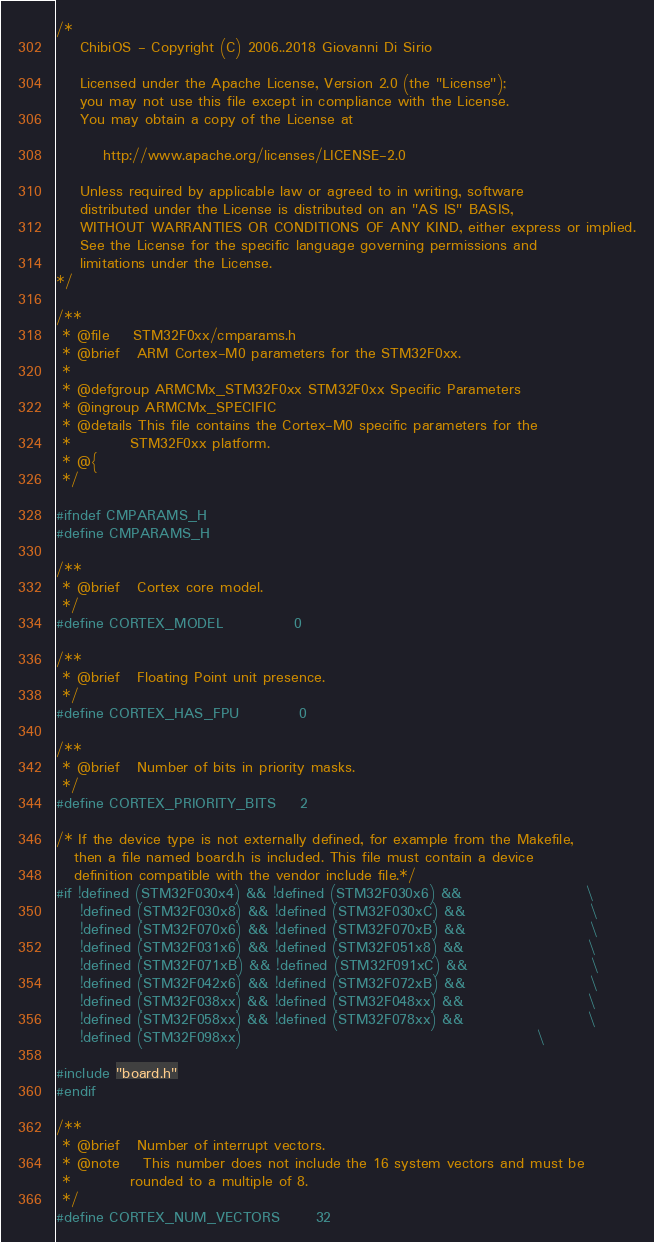Convert code to text. <code><loc_0><loc_0><loc_500><loc_500><_C_>/*
    ChibiOS - Copyright (C) 2006..2018 Giovanni Di Sirio

    Licensed under the Apache License, Version 2.0 (the "License");
    you may not use this file except in compliance with the License.
    You may obtain a copy of the License at

        http://www.apache.org/licenses/LICENSE-2.0

    Unless required by applicable law or agreed to in writing, software
    distributed under the License is distributed on an "AS IS" BASIS,
    WITHOUT WARRANTIES OR CONDITIONS OF ANY KIND, either express or implied.
    See the License for the specific language governing permissions and
    limitations under the License.
*/

/**
 * @file    STM32F0xx/cmparams.h
 * @brief   ARM Cortex-M0 parameters for the STM32F0xx.
 *
 * @defgroup ARMCMx_STM32F0xx STM32F0xx Specific Parameters
 * @ingroup ARMCMx_SPECIFIC
 * @details This file contains the Cortex-M0 specific parameters for the
 *          STM32F0xx platform.
 * @{
 */

#ifndef CMPARAMS_H
#define CMPARAMS_H

/**
 * @brief   Cortex core model.
 */
#define CORTEX_MODEL            0

/**
 * @brief   Floating Point unit presence.
 */
#define CORTEX_HAS_FPU          0

/**
 * @brief   Number of bits in priority masks.
 */
#define CORTEX_PRIORITY_BITS    2

/* If the device type is not externally defined, for example from the Makefile,
   then a file named board.h is included. This file must contain a device
   definition compatible with the vendor include file.*/
#if !defined (STM32F030x4) && !defined (STM32F030x6) &&                     \
    !defined (STM32F030x8) && !defined (STM32F030xC) &&                     \
    !defined (STM32F070x6) && !defined (STM32F070xB) &&                     \
    !defined (STM32F031x6) && !defined (STM32F051x8) &&                     \
    !defined (STM32F071xB) && !defined (STM32F091xC) &&                     \
    !defined (STM32F042x6) && !defined (STM32F072xB) &&                     \
    !defined (STM32F038xx) && !defined (STM32F048xx) &&                     \
    !defined (STM32F058xx) && !defined (STM32F078xx) &&                     \
    !defined (STM32F098xx)                                                  \

#include "board.h"
#endif

/**
 * @brief   Number of interrupt vectors.
 * @note    This number does not include the 16 system vectors and must be
 *          rounded to a multiple of 8.
 */
#define CORTEX_NUM_VECTORS      32
</code> 